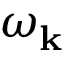<formula> <loc_0><loc_0><loc_500><loc_500>\omega _ { k }</formula> 